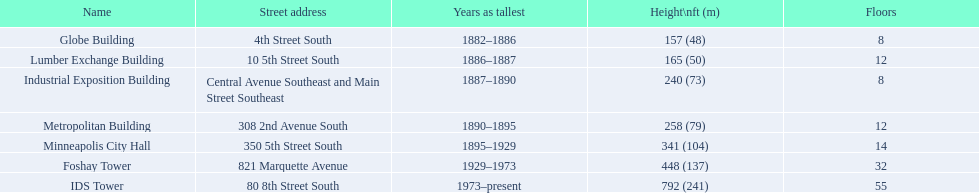What are the measurements of the buildings' heights? 157 (48), 165 (50), 240 (73), 258 (79), 341 (104), 448 (137), 792 (241). Which building has a height of 240 feet? Industrial Exposition Building. 